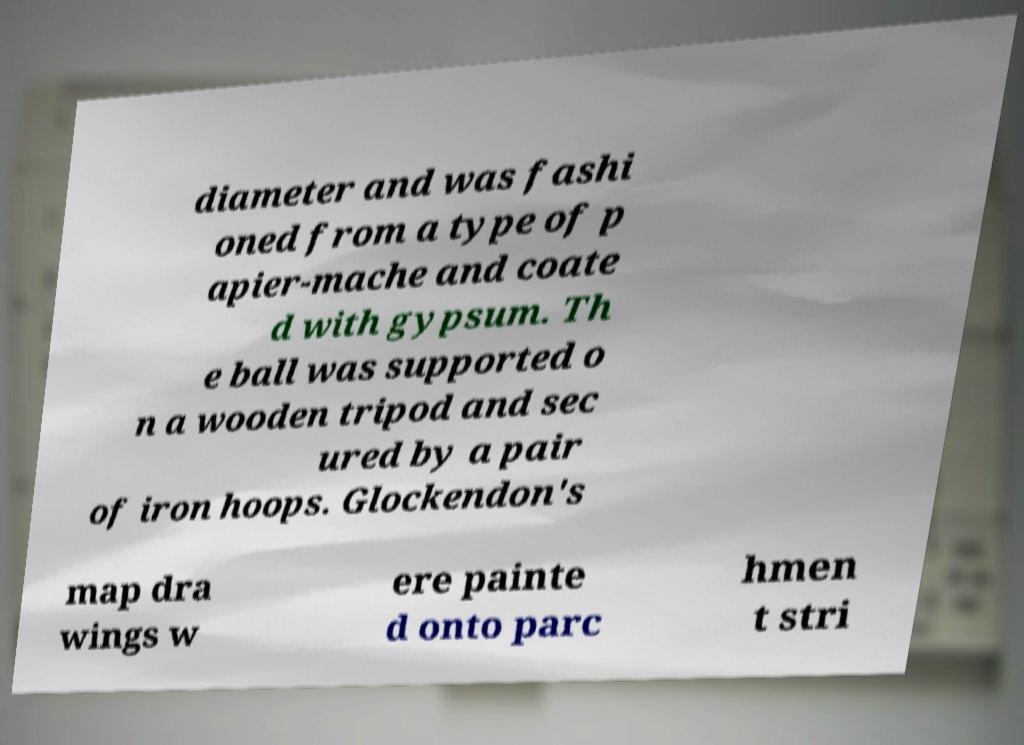Please read and relay the text visible in this image. What does it say? diameter and was fashi oned from a type of p apier-mache and coate d with gypsum. Th e ball was supported o n a wooden tripod and sec ured by a pair of iron hoops. Glockendon's map dra wings w ere painte d onto parc hmen t stri 